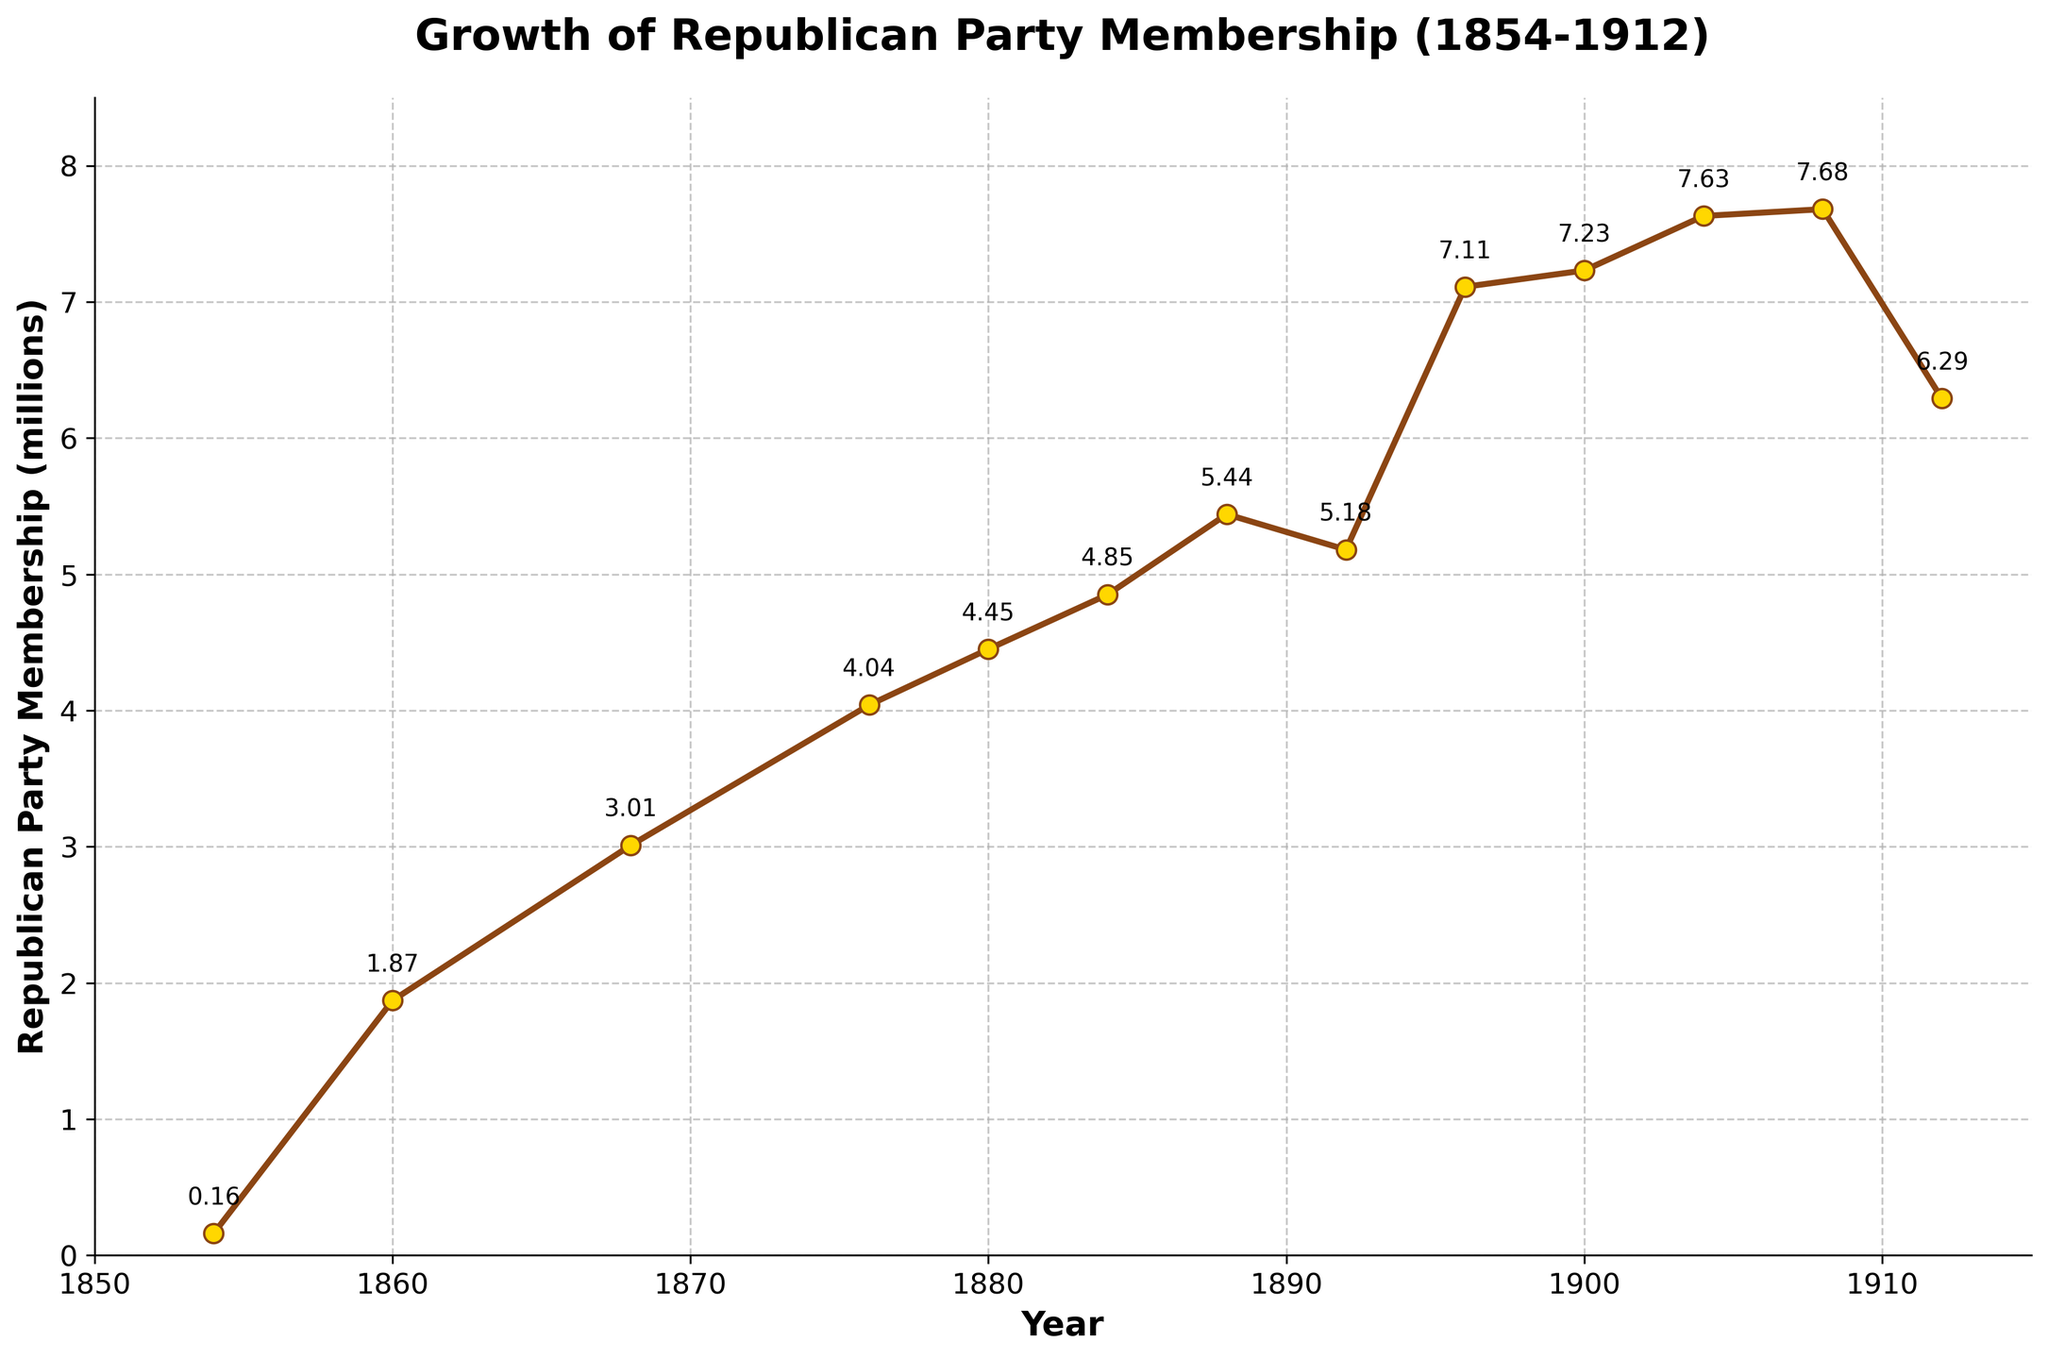Which year saw the highest membership of the Republican Party? Look for the peak point on the line chart. The highest point is in 1908 with a membership of 7.68 million.
Answer: 1908 What was the Republican Party membership in 1860? Refer to the y-axis value at the year 1860. The membership was 1.87 million.
Answer: 1.87 million By how much did the membership increase from 1854 to 1860? Subtract the membership in 1854 from the membership in 1860: 1.87 - 0.16 = 1.71 million.
Answer: 1.71 million What trend can you observe in the Republican Party membership between 1896 and 1912? Observe the line plot from 1896 to 1912. The trend shows a rise to a peak in 1908, followed by a decline.
Answer: Rise then decline How did the membership change during the Gilded Age (approximately 1870 to 1900)? Observe the membership values from 1870 to 1900. There is a general upward trend from roughly 4 million in the 1870s to over 7 million at the turn of the century.
Answer: Upward trend What membership value annotates the highest peak on the chart? Identify the peak of the curve. The annotated value at the highest peak in 1908 is 7.68 million.
Answer: 7.68 million Was the membership in 1892 greater or less than in 1888? Compare the y-axis values for 1892 and 1888. It was less in 1892 (5.18 million) than in 1888 (5.44 million).
Answer: Less Calculate the average membership from 1854 to 1912. Add all the membership values and divide by the number of years recorded. The sum is 61.93 million across 13 data points, so the average is 61.93 / 13 = 4.76 million.
Answer: 4.76 million How does the membership in 1900 compare to 1912? Observe the y-axis values for 1900 and 1912. Membership in 1900 was 7.23 million, while in 1912, it was 6.29 million.
Answer: Higher in 1900 What was the membership growth from the beginning of the chart (1854) to the end (1912)? Subtract the membership value in 1854 from that in 1912: 6.29 - 0.16 = 6.13 million.
Answer: 6.13 million 